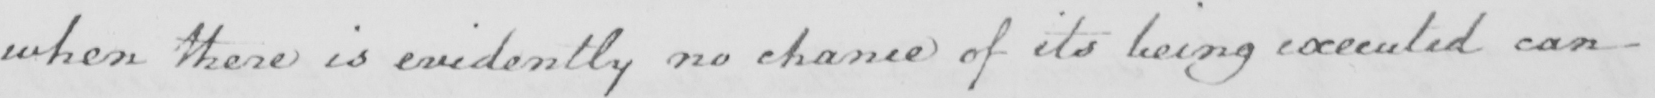Can you read and transcribe this handwriting? when there is evidently no chance of its being executed can 